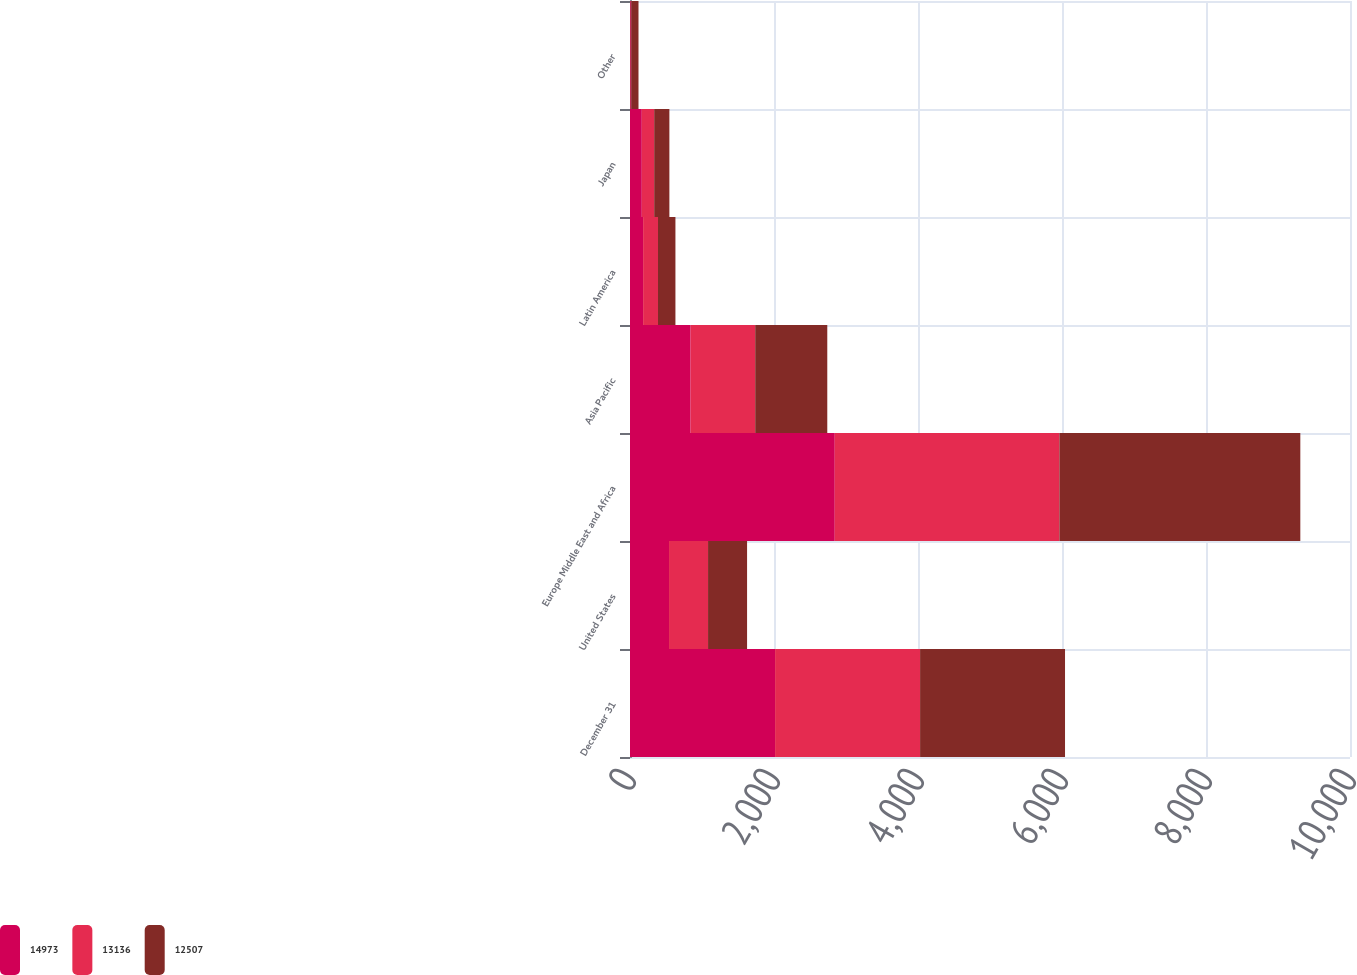Convert chart to OTSL. <chart><loc_0><loc_0><loc_500><loc_500><stacked_bar_chart><ecel><fcel>December 31<fcel>United States<fcel>Europe Middle East and Africa<fcel>Asia Pacific<fcel>Latin America<fcel>Japan<fcel>Other<nl><fcel>14973<fcel>2015<fcel>542<fcel>2844<fcel>842<fcel>182<fcel>164<fcel>8<nl><fcel>13136<fcel>2014<fcel>542<fcel>3120<fcel>897<fcel>207<fcel>172<fcel>13<nl><fcel>12507<fcel>2013<fcel>542<fcel>3346<fcel>1001<fcel>242<fcel>211<fcel>97<nl></chart> 